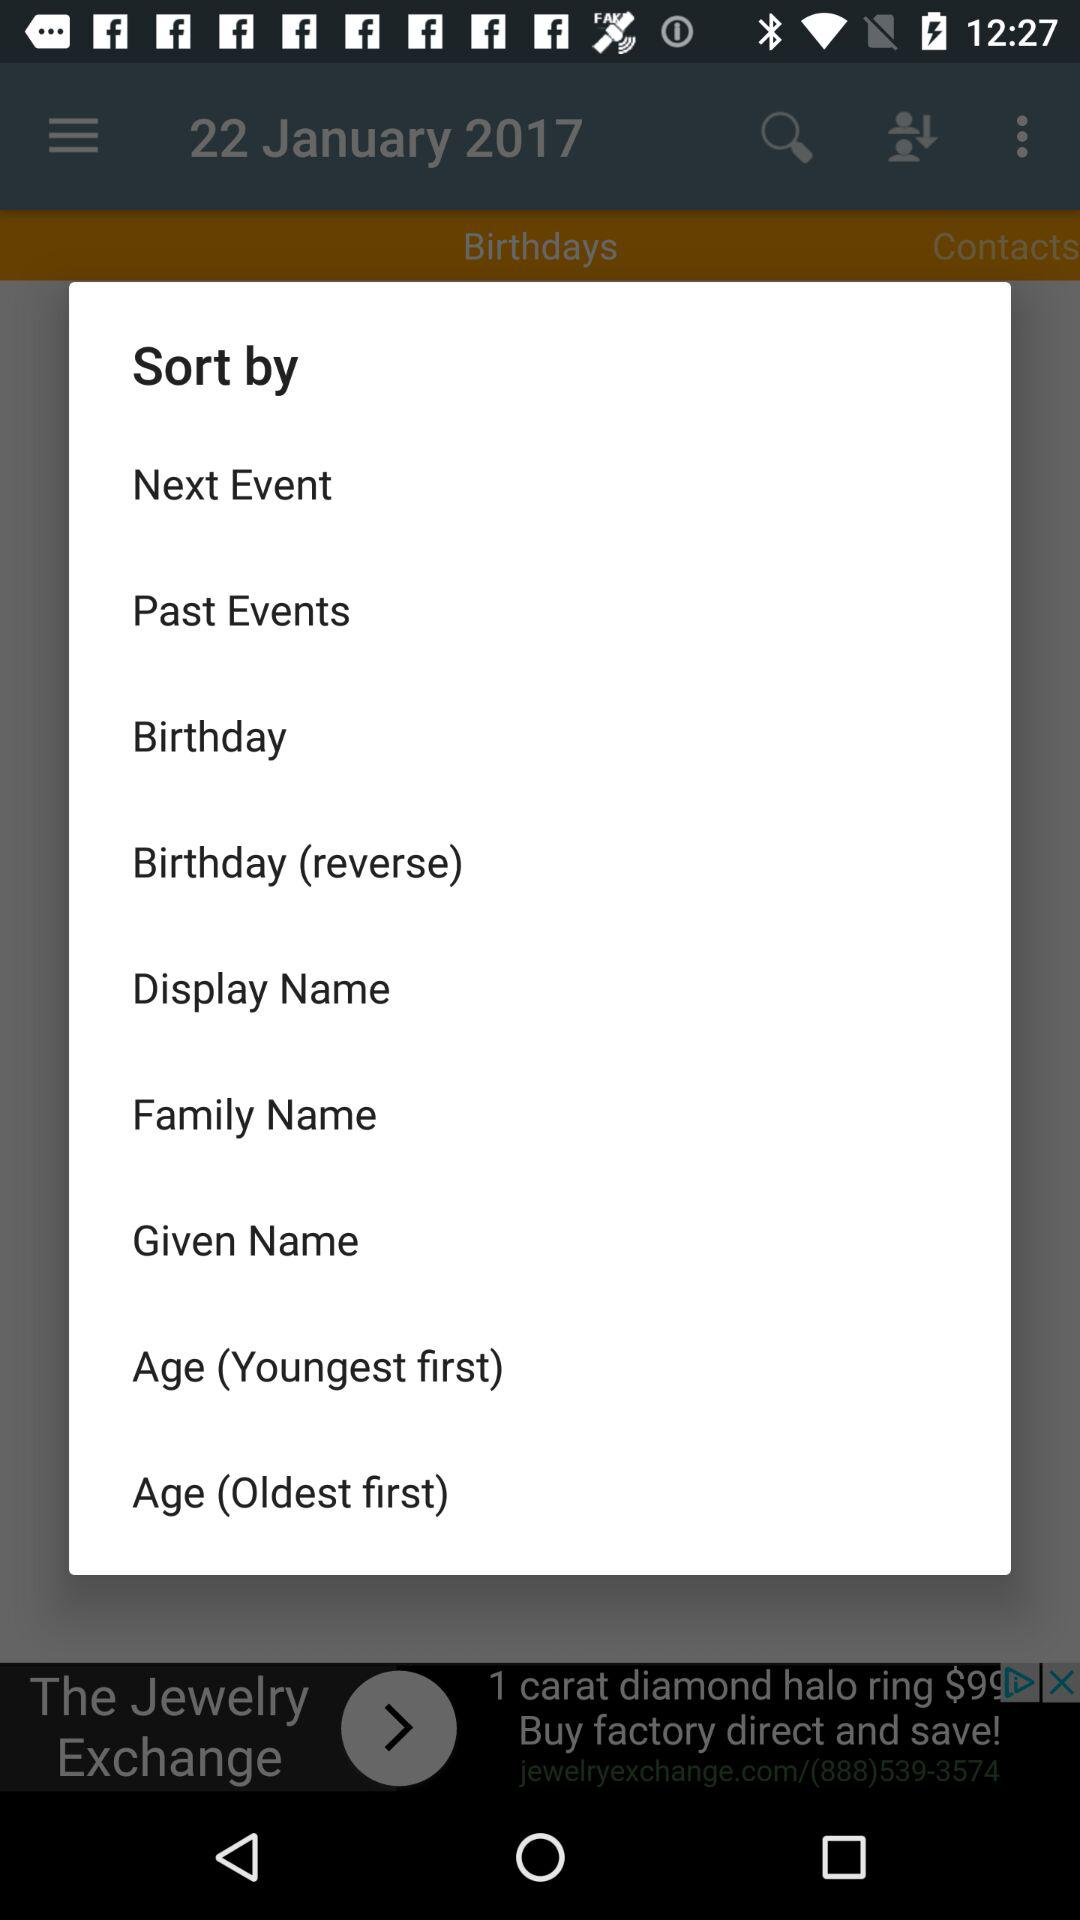What is the given date? The given date is January 22, 2017. 